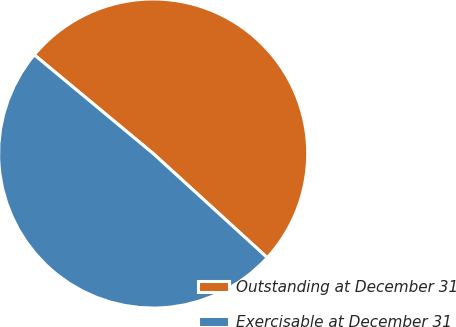<chart> <loc_0><loc_0><loc_500><loc_500><pie_chart><fcel>Outstanding at December 31<fcel>Exercisable at December 31<nl><fcel>50.75%<fcel>49.25%<nl></chart> 